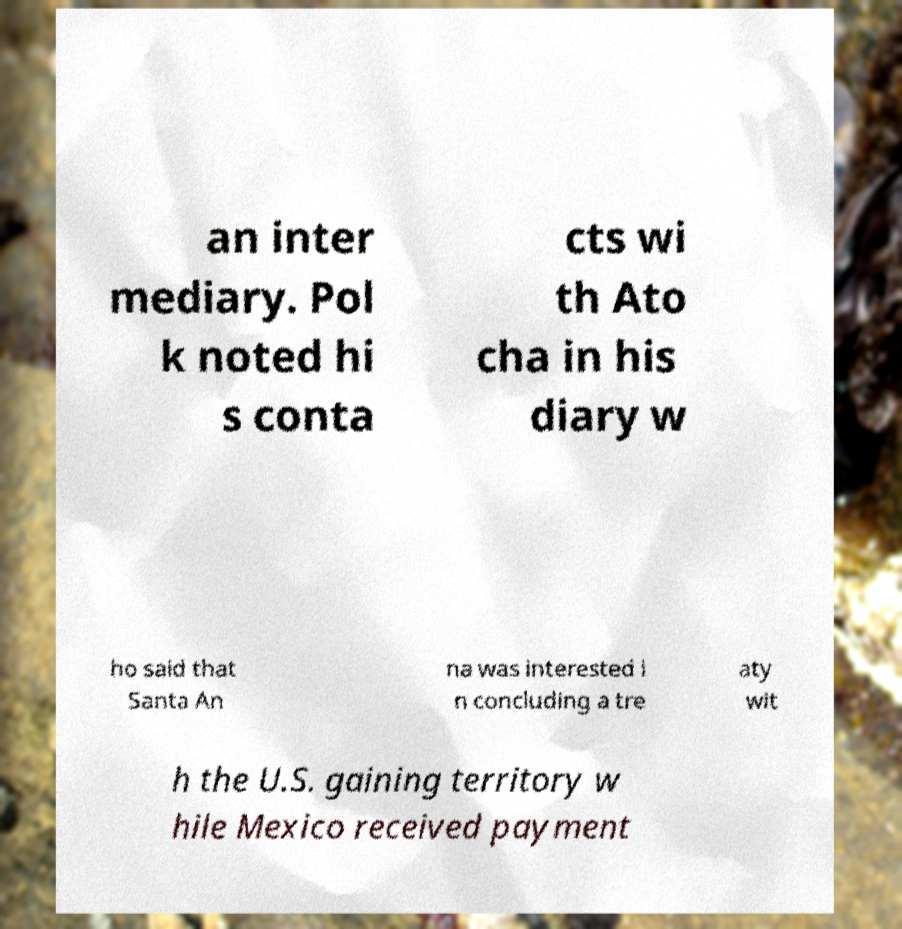There's text embedded in this image that I need extracted. Can you transcribe it verbatim? an inter mediary. Pol k noted hi s conta cts wi th Ato cha in his diary w ho said that Santa An na was interested i n concluding a tre aty wit h the U.S. gaining territory w hile Mexico received payment 